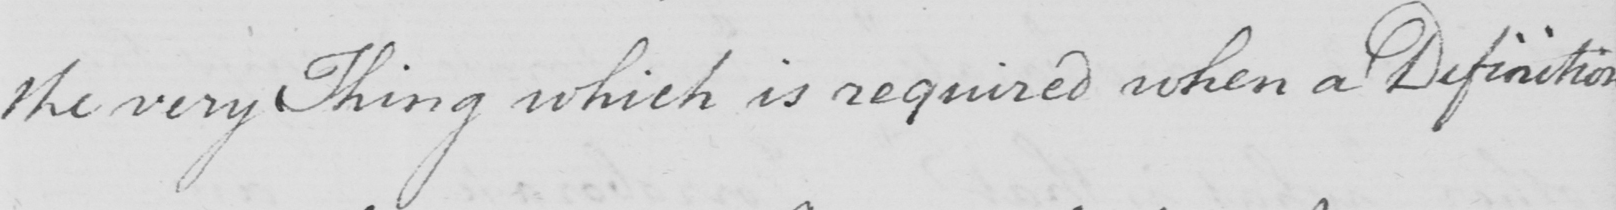Please transcribe the handwritten text in this image. the very Thing which is required when a Definition 